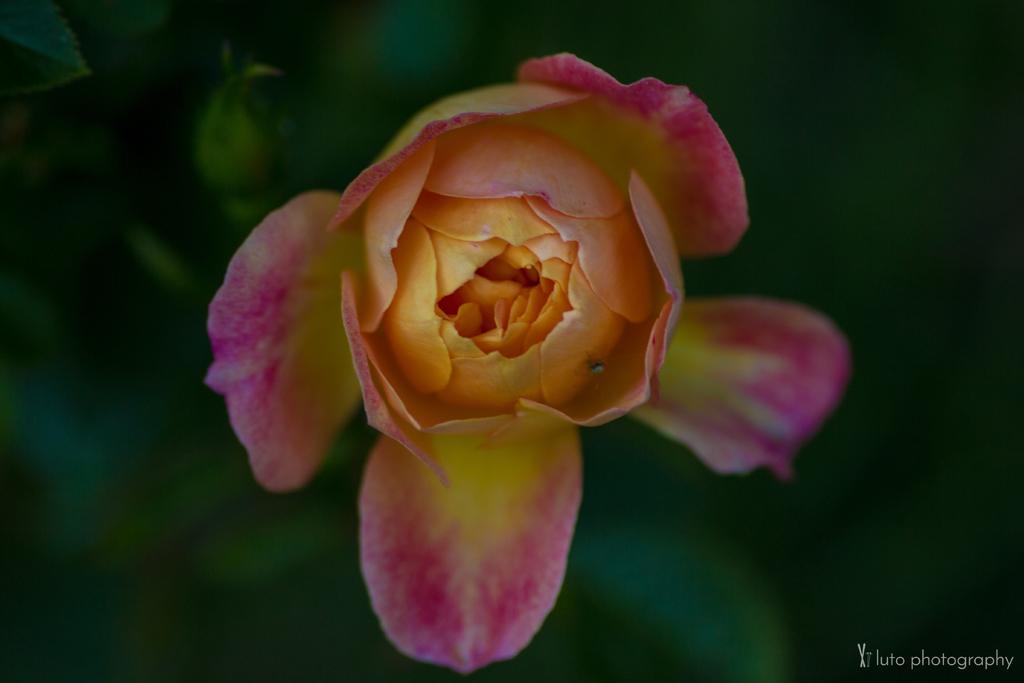In one or two sentences, can you explain what this image depicts? There is a pink and yellow color flower. In the background it is green and blurred. At the right bottom corner there is a watermark. 